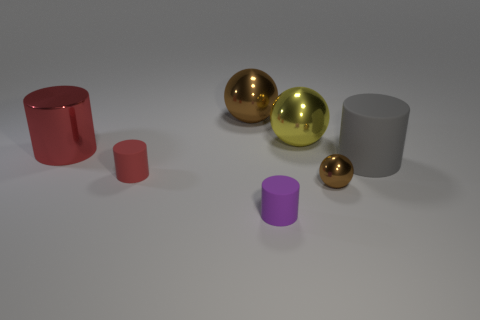Subtract all red matte cylinders. How many cylinders are left? 3 Subtract all purple spheres. How many red cylinders are left? 2 Subtract 1 spheres. How many spheres are left? 2 Add 1 big brown matte cylinders. How many objects exist? 8 Subtract all gray cylinders. How many cylinders are left? 3 Subtract all gray spheres. Subtract all gray cylinders. How many spheres are left? 3 Subtract all spheres. How many objects are left? 4 Subtract all tiny red matte things. Subtract all brown spheres. How many objects are left? 4 Add 7 brown spheres. How many brown spheres are left? 9 Add 2 red things. How many red things exist? 4 